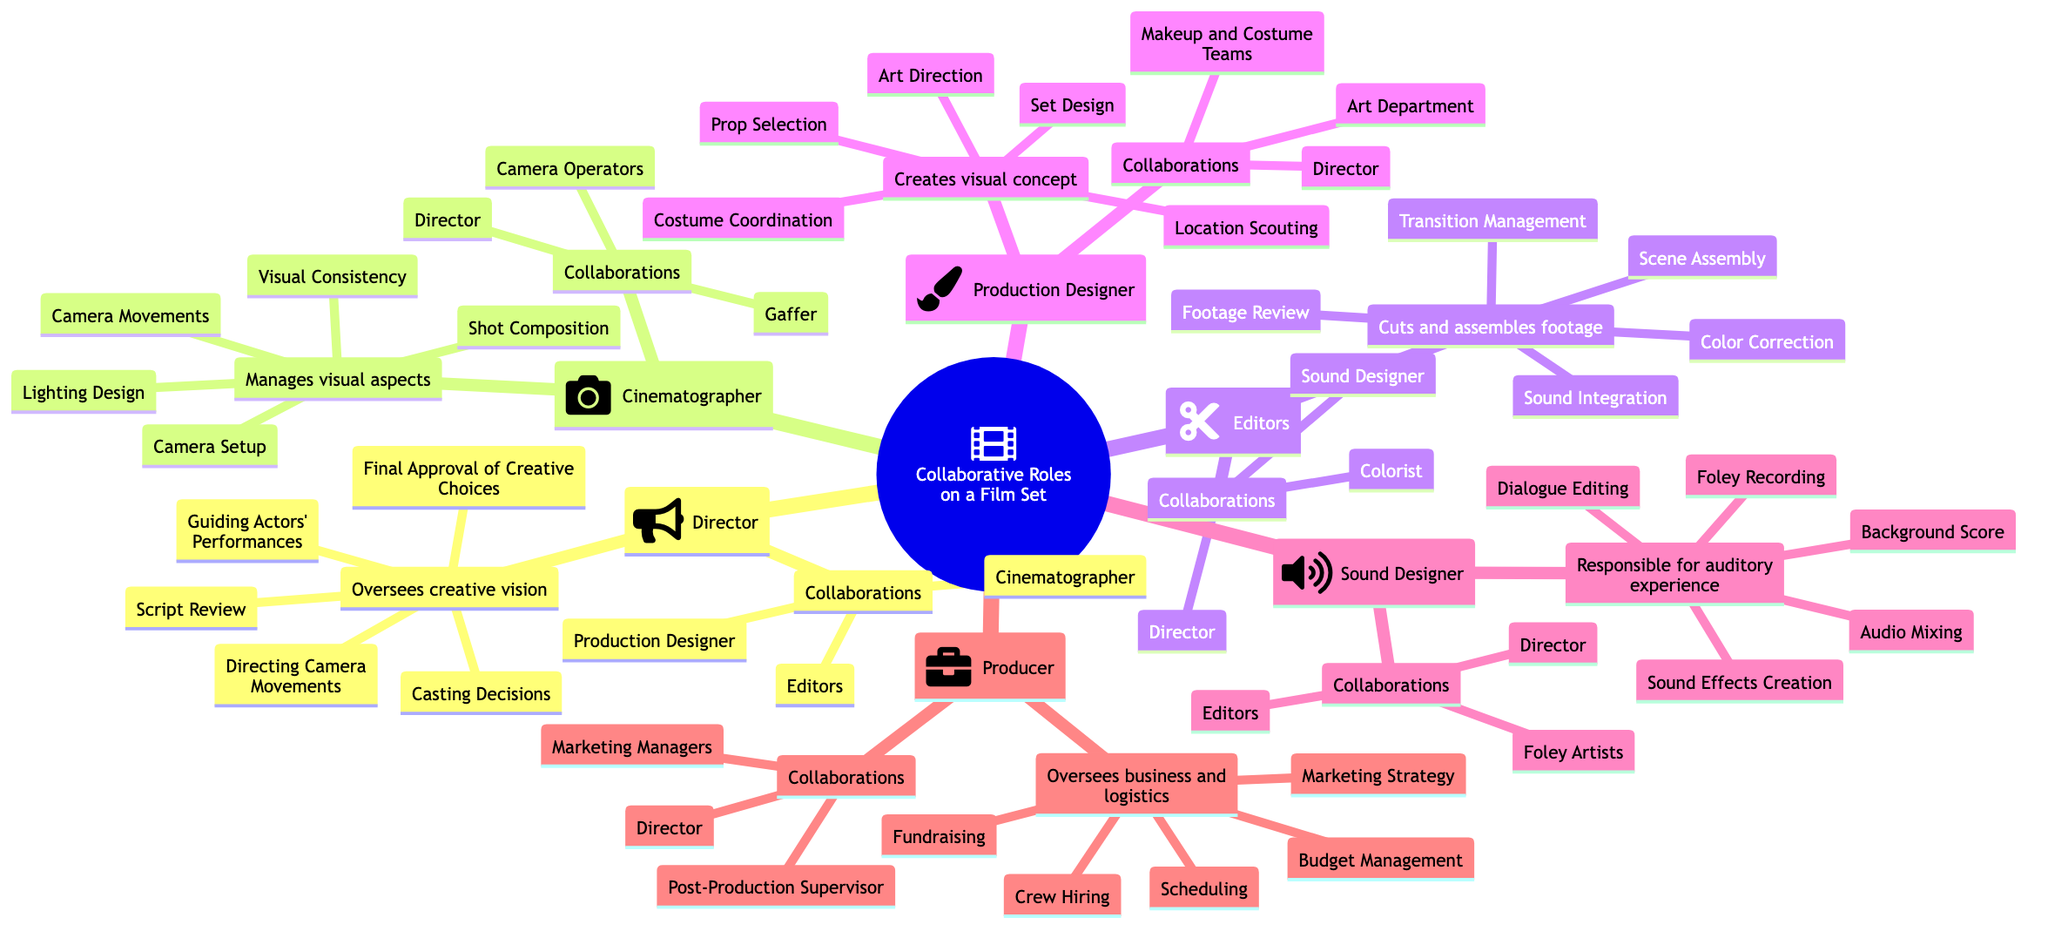What is the main role of the Director? The diagram states that the Director oversees the creative vision of the film, which encompasses various responsibilities.
Answer: Oversees creative vision How many main roles are there in the film set mind map? The mind map features six main roles: Director, Cinematographer, Editors, Production Designer, Sound Designer, and Producer. Count them to get the total.
Answer: Six Who collaborates with the Editor? The diagram indicates that the Editor collaborates with the Director, Sound Designer, and Colorist. By looking at the collaborations listed under Editors, we can identify them.
Answer: Director, Sound Designer, Colorist What is one responsibility of the Cinematographer? Reviewing the responsibilities listed for the Cinematographer shows several tasks, one of which is Camera Setup.
Answer: Camera Setup Which role manages the auditory experience? According to the diagram, the Sound Designer is responsible for the auditory experience of the film. This is explicitly mentioned under the Sound Designer section.
Answer: Sound Designer How many responsibilities does the Production Designer have listed? Upon reviewing the responsibilities listed under the Production Designer, we see there are five responsibilities enumerated. Counting each item gives the total.
Answer: Five What is the collaboration between the Producer and the Director? The diagram shows that the Producer collaborates with the Director, as listed under the Producer's collaborations. This can be directly noted from the mind map.
Answer: Director Which role is associated with lighting design? The responsibilities listed for the Cinematographer include Lighting Design, making it clear that this role is associated with this task.
Answer: Cinematographer What is the responsibility of the Sound Designer related to sound? The diagram lists several responsibilities for the Sound Designer, one being Sound Effects Creation, which directly relates to sound.
Answer: Sound Effects Creation 